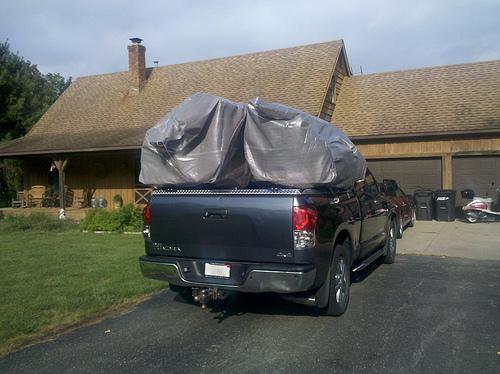How many trucks are there?
Give a very brief answer. 1. 